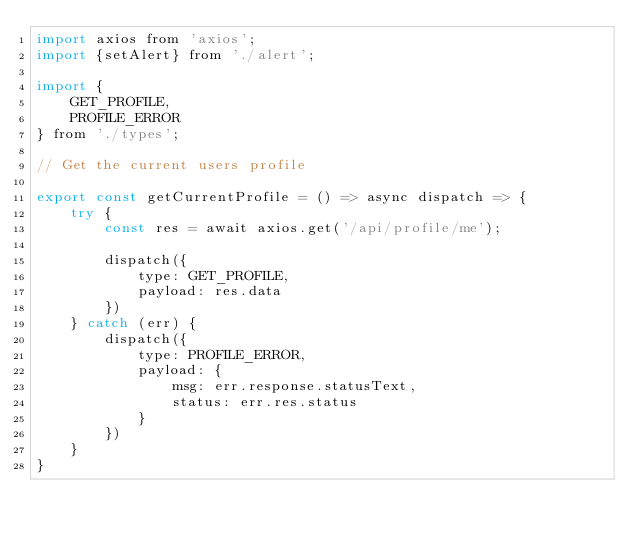Convert code to text. <code><loc_0><loc_0><loc_500><loc_500><_JavaScript_>import axios from 'axios';
import {setAlert} from './alert';

import {
    GET_PROFILE,
    PROFILE_ERROR
} from './types';

// Get the current users profile

export const getCurrentProfile = () => async dispatch => {
    try {
        const res = await axios.get('/api/profile/me');

        dispatch({
            type: GET_PROFILE, 
            payload: res.data
        })
    } catch (err) {
        dispatch({
            type: PROFILE_ERROR, 
            payload: {
                msg: err.response.statusText, 
                status: err.res.status
            }
        })
    }
}</code> 